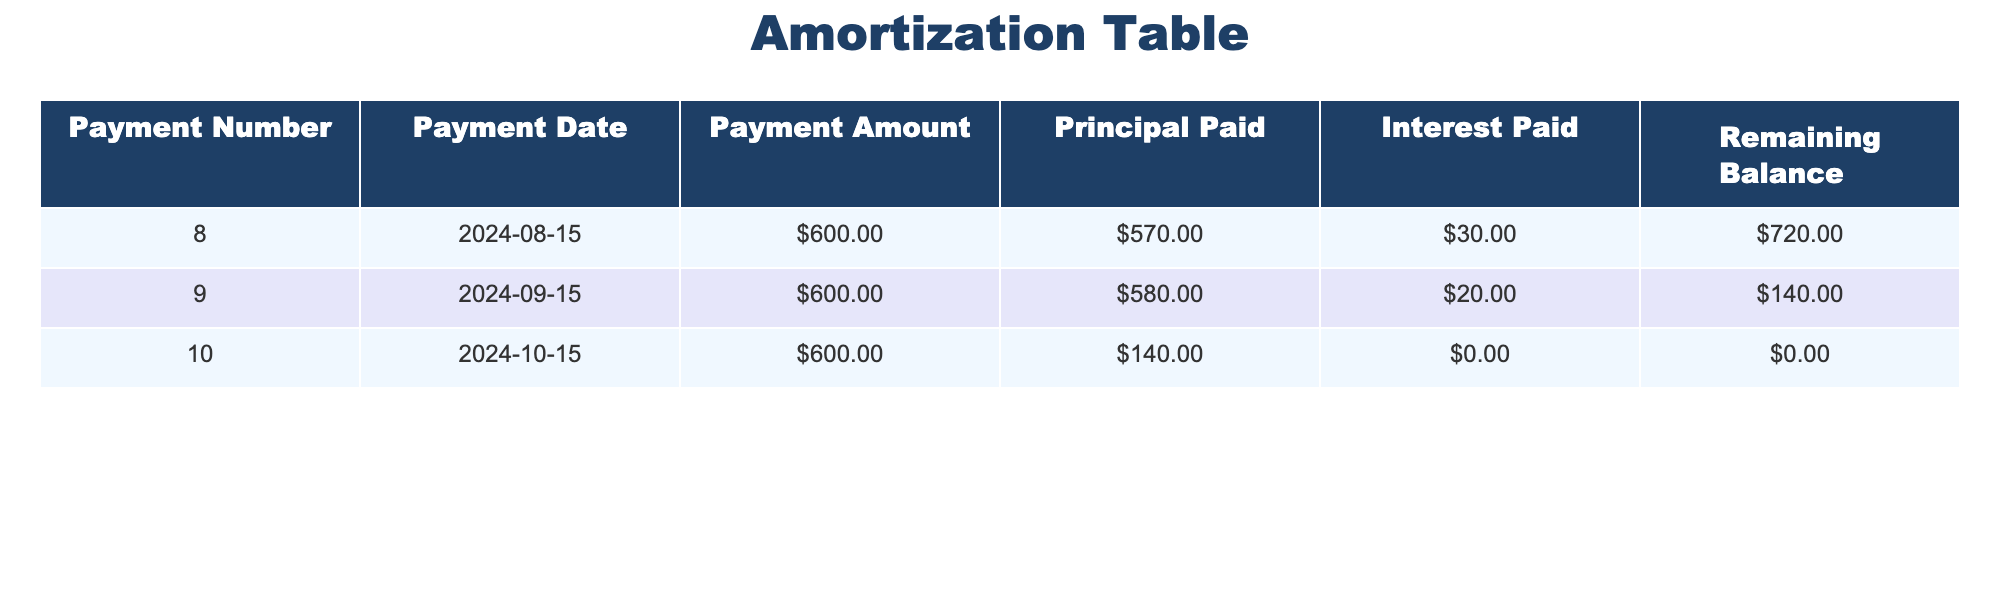What is the payment amount for the 9th payment? The table lists the payment amounts for each entry. For the 9th payment, the corresponding value under the "Payment Amount" column is $600.00.
Answer: $600.00 What is the total principal paid over all three payments? To find the total principal paid, add the "Principal Paid" amounts from each payment: $570.00 (8th) + $580.00 (9th) + $140.00 (10th) = $1290.00.
Answer: $1290.00 Is there any interest payment in the 10th payment? The "Interest Paid" for the 10th payment is recorded as $0.00. This means there is no interest payment for that installment.
Answer: No What is the remaining balance after the 9th payment? The remaining balance after the 9th payment is found in the "Remaining Balance" column for that row, which indicates a balance of $140.00.
Answer: $140.00 What is the total amount paid over the first three payments? To calculate the total amount paid, sum up the payment amounts for each of the three payments: $600.00 (8th) + $600.00 (9th) + $600.00 (10th) = $1800.00.
Answer: $1800.00 Did the principal paid increase or decrease from the 8th to the 9th payment? The principal paid increased from $570.00 (8th) to $580.00 (9th), showing that the amount going towards the principal rose.
Answer: Increased What is the average interest paid per payment over the three payments? The average can be determined by calculating the sum of the interest paid amounts: $30.00 (8th) + $20.00 (9th) + $0.00 (10th) = $50.00; then divide by 3, resulting in an average of $16.67.
Answer: $16.67 How much principal is paid in the final payment compared to the total principal paid in the previous payments? The principal paid in the final payment (10th) is $140.00. The total paid previously was $570.00 + $580.00 = $1150.00. Comparing the two, $140.00 is significantly lower than the previous total.
Answer: Lower What is the difference in payment amounts between the 8th and the 10th payments? The payment amount for the 8th payment is $600.00, and the 10th payment is also $600.00. Therefore, the difference is $600.00 - $600.00 = $0.00.
Answer: $0.00 